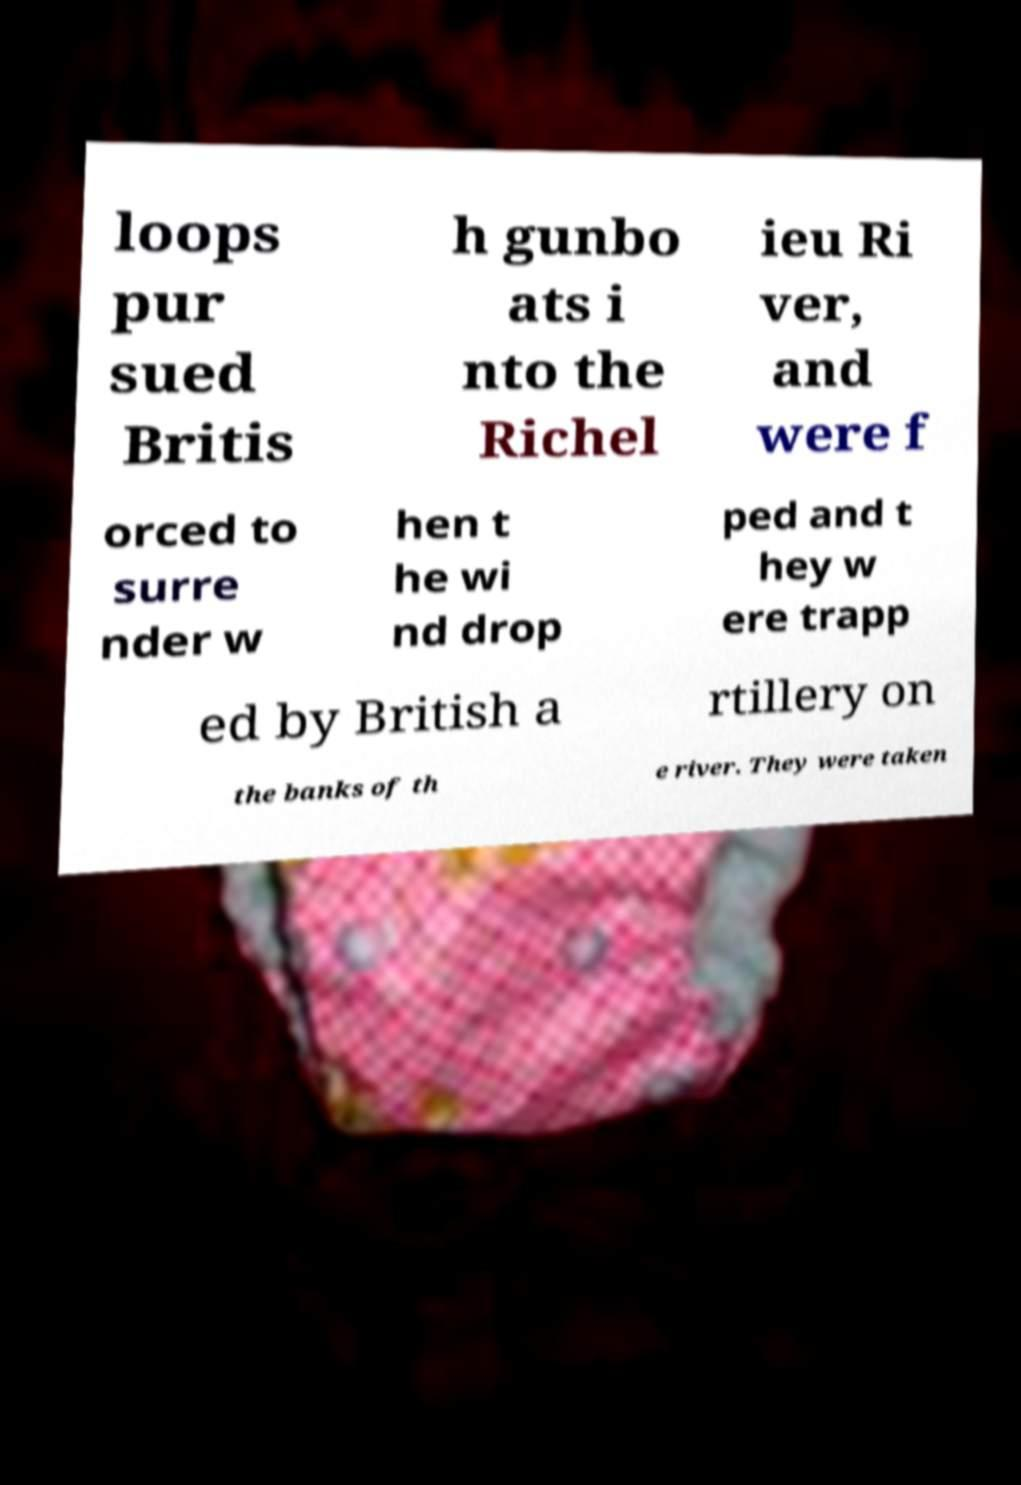Could you assist in decoding the text presented in this image and type it out clearly? loops pur sued Britis h gunbo ats i nto the Richel ieu Ri ver, and were f orced to surre nder w hen t he wi nd drop ped and t hey w ere trapp ed by British a rtillery on the banks of th e river. They were taken 